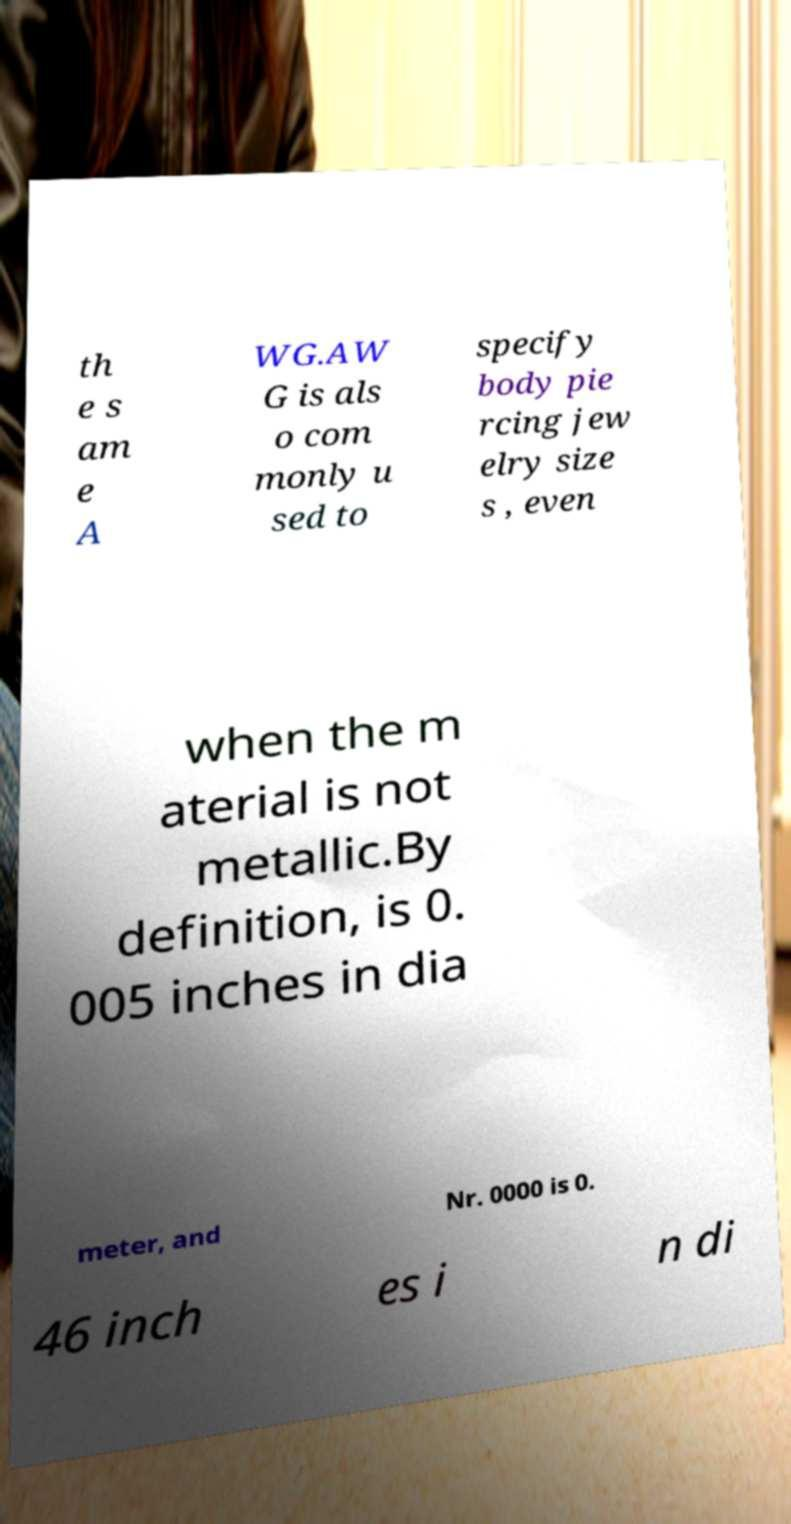For documentation purposes, I need the text within this image transcribed. Could you provide that? th e s am e A WG.AW G is als o com monly u sed to specify body pie rcing jew elry size s , even when the m aterial is not metallic.By definition, is 0. 005 inches in dia meter, and Nr. 0000 is 0. 46 inch es i n di 